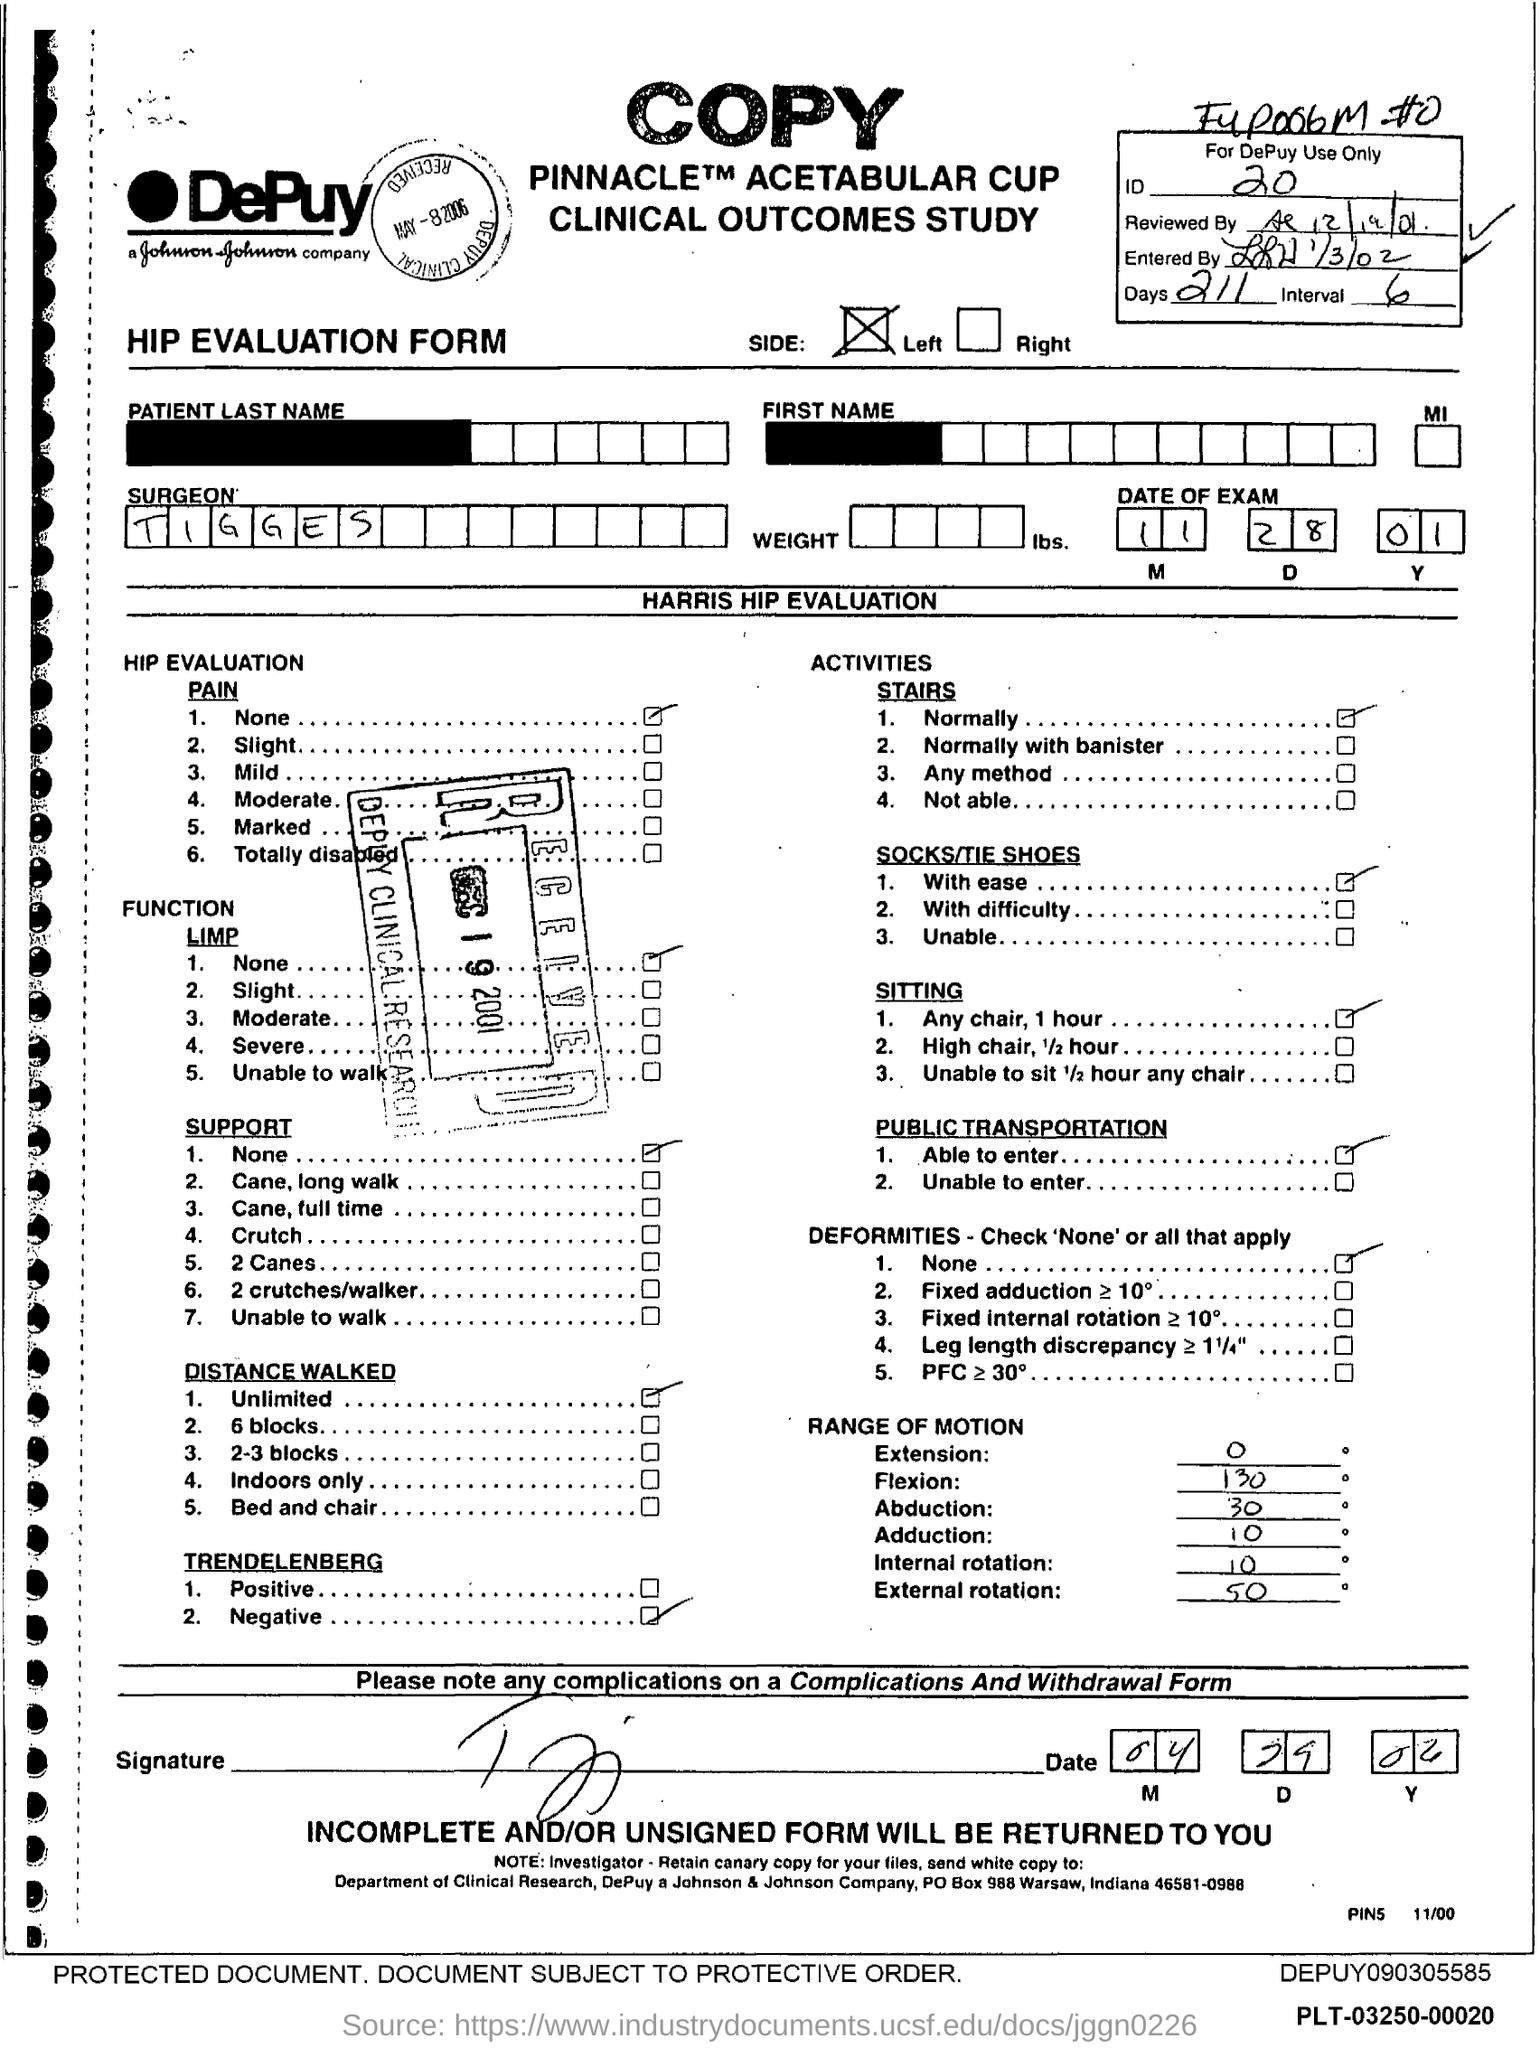What is the ID Number?
Make the answer very short. 20. What is the number of days?
Offer a terse response. 211. What is the name of the Surgeon?
Your answer should be very brief. Tigges. 